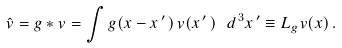<formula> <loc_0><loc_0><loc_500><loc_500>\hat { v } = g * v = \int g ( x - x ^ { \, \prime \, } ) \, v ( x ^ { \, \prime \, } ) \ d ^ { \, 3 } x ^ { \, \prime } \equiv L _ { g } v ( x ) \, .</formula> 